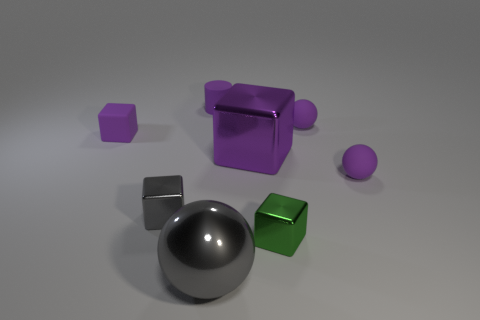Is the color of the big block the same as the small rubber block?
Offer a very short reply. Yes. There is a rubber ball that is in front of the rubber cube; is its color the same as the small cylinder?
Your answer should be compact. Yes. What number of other things are there of the same color as the rubber cylinder?
Give a very brief answer. 4. How many things are either small things or tiny brown cubes?
Offer a terse response. 6. How many objects are either small purple rubber cubes or purple matte cubes that are behind the big ball?
Provide a short and direct response. 1. Is the small purple block made of the same material as the small green block?
Ensure brevity in your answer.  No. What number of other things are there of the same material as the small gray thing
Ensure brevity in your answer.  3. Is the number of large gray objects greater than the number of gray metal things?
Your answer should be compact. No. There is a tiny purple matte thing that is in front of the large purple metallic cube; does it have the same shape as the tiny green object?
Your response must be concise. No. Is the number of tiny green blocks less than the number of small brown things?
Provide a short and direct response. No. 